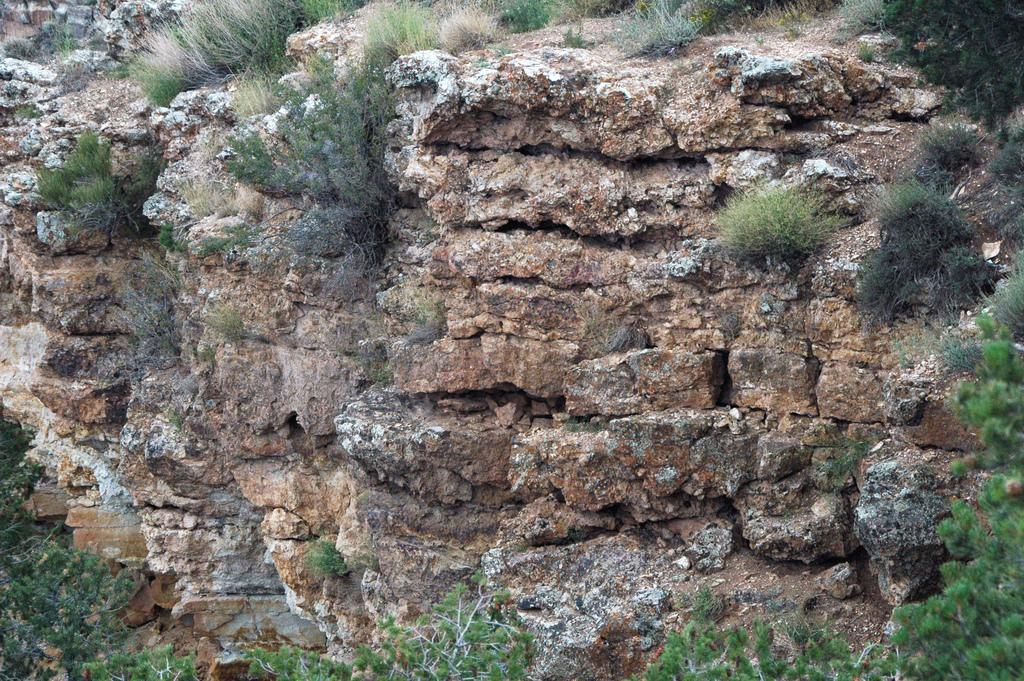What type of natural landscape is depicted in the image? The image features mountains. What other types of vegetation can be seen in the image? There are plants, grass, and trees in the image. Where are the trees located in the image? The trees are at the bottom of the image. What other geological features are present in the image? There are rocks in the front of the image. What type of pleasure can be seen enjoying the scenery in the image? There is no indication of any person or creature experiencing pleasure in the image. 